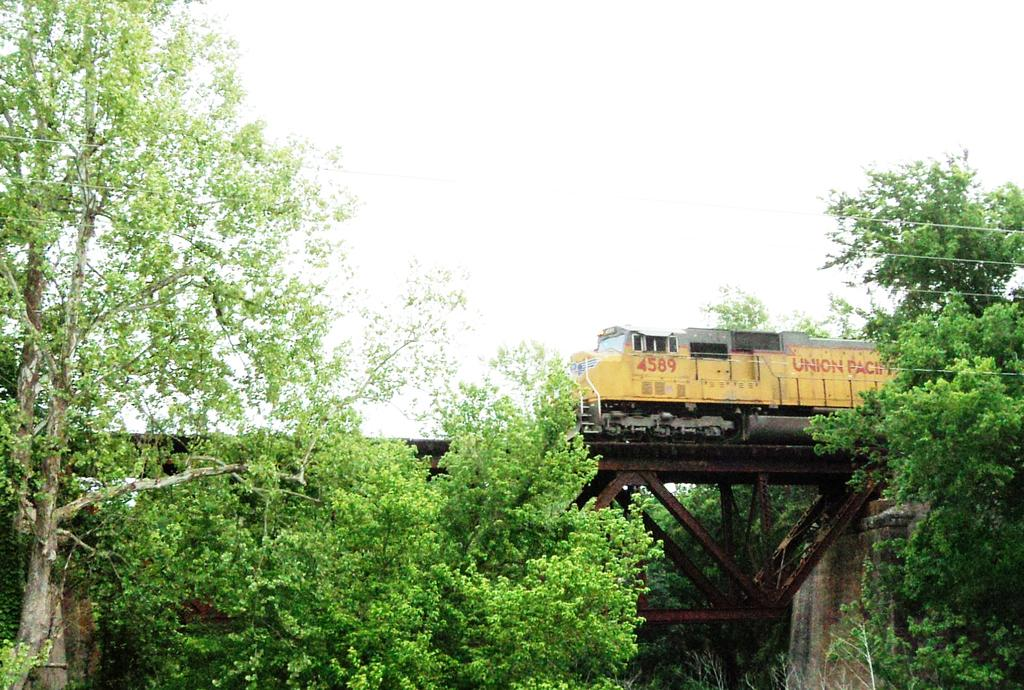What can be seen in the foreground of the picture? There are trees and cables in the foreground of the picture. What is located in the center of the picture? There is a railway track in the center of the picture. What is on the railway track? There is a train on the railway track. What is the condition of the sky in the picture? The sky is cloudy in the picture. What type of crayon is being used to draw the train in the image? There is no crayon present in the image; it is a photograph of a real train on a railway track. What nation is the train representing in the image? The image does not provide any information about the nation the train represents. 